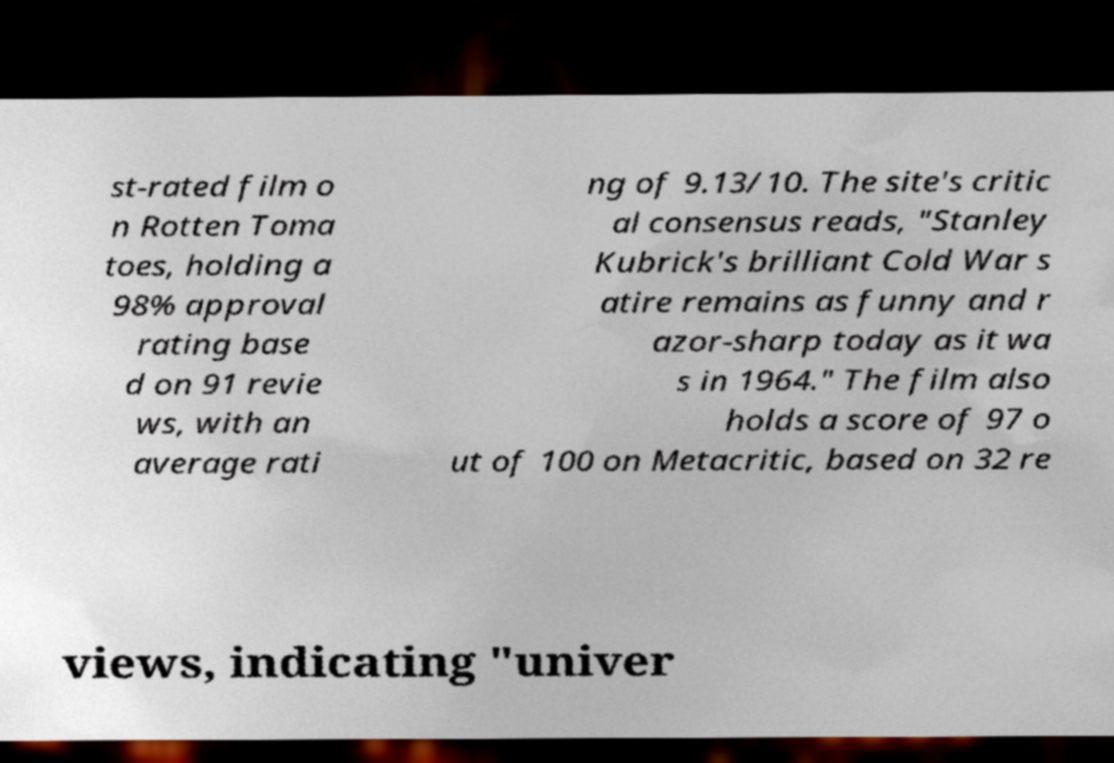What messages or text are displayed in this image? I need them in a readable, typed format. st-rated film o n Rotten Toma toes, holding a 98% approval rating base d on 91 revie ws, with an average rati ng of 9.13/10. The site's critic al consensus reads, "Stanley Kubrick's brilliant Cold War s atire remains as funny and r azor-sharp today as it wa s in 1964." The film also holds a score of 97 o ut of 100 on Metacritic, based on 32 re views, indicating "univer 